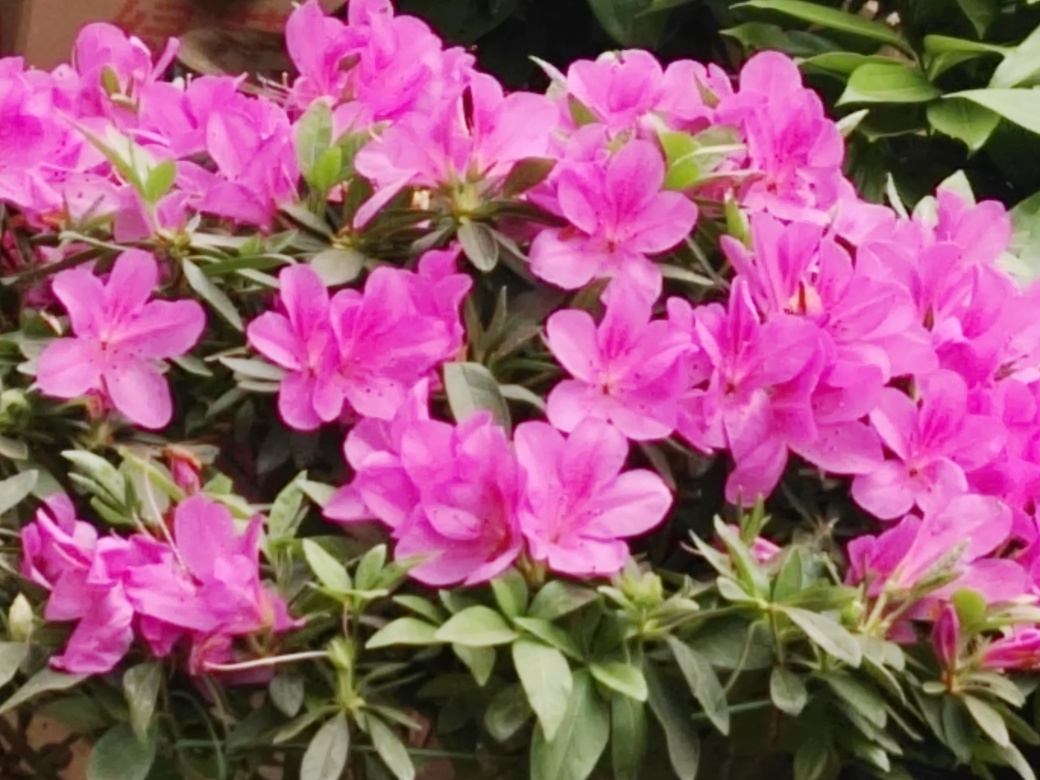Could you suggest an ideal setting for these flowers if someone wanted to plant them in their own garden? Certainly! Azaleas thrive in well-drained, slightly acidic soil. They prefer partial shade, as intense sunlight can damage the blooms. A spot under a tree, where they can receive dappled sunlight, is ideal. Ensure they have enough space, as they can grow quite broad, and provide mulch to retain moisture and protect roots. Plant them as a border, or as a colorful emphasis in a shade garden for a delightful spring display. 